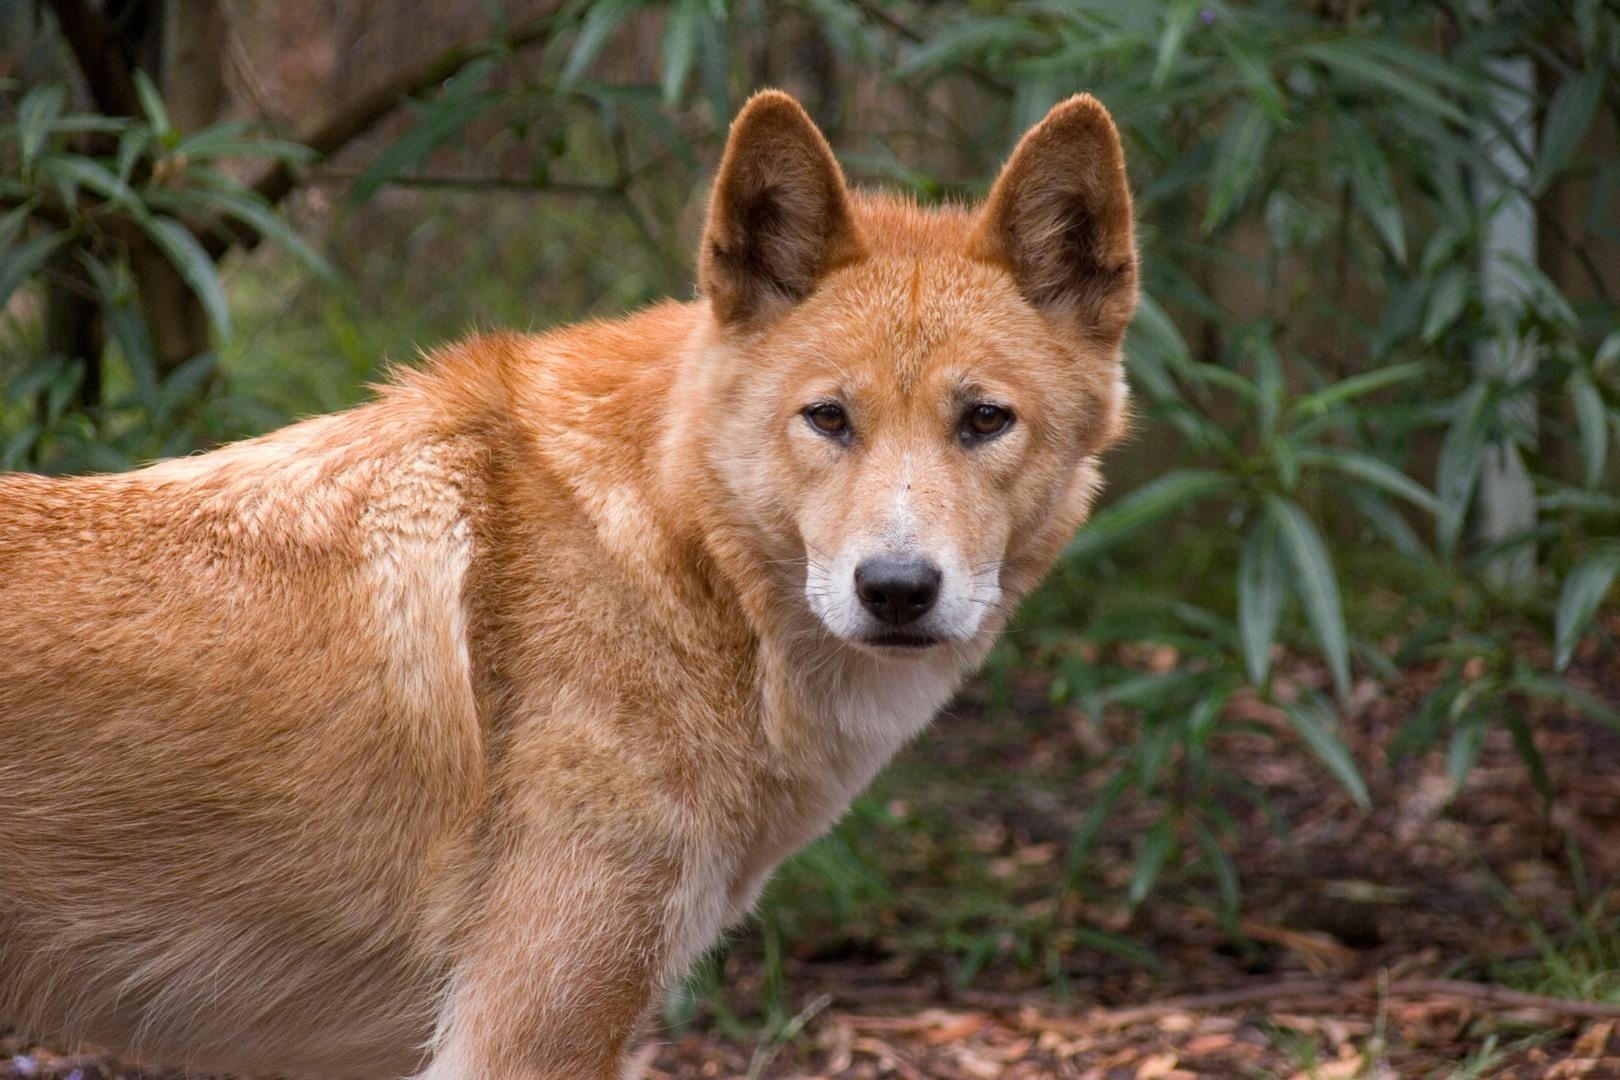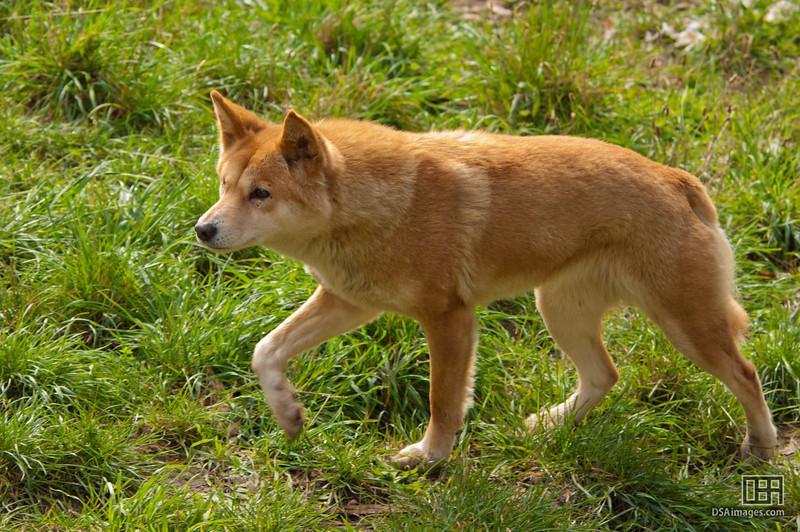The first image is the image on the left, the second image is the image on the right. For the images displayed, is the sentence "The canine on the left is laying down, the canine on the right is standing up." factually correct? Answer yes or no. No. The first image is the image on the left, the second image is the image on the right. Analyze the images presented: Is the assertion "One of the images shows exactly one animal in the grass alone." valid? Answer yes or no. Yes. 